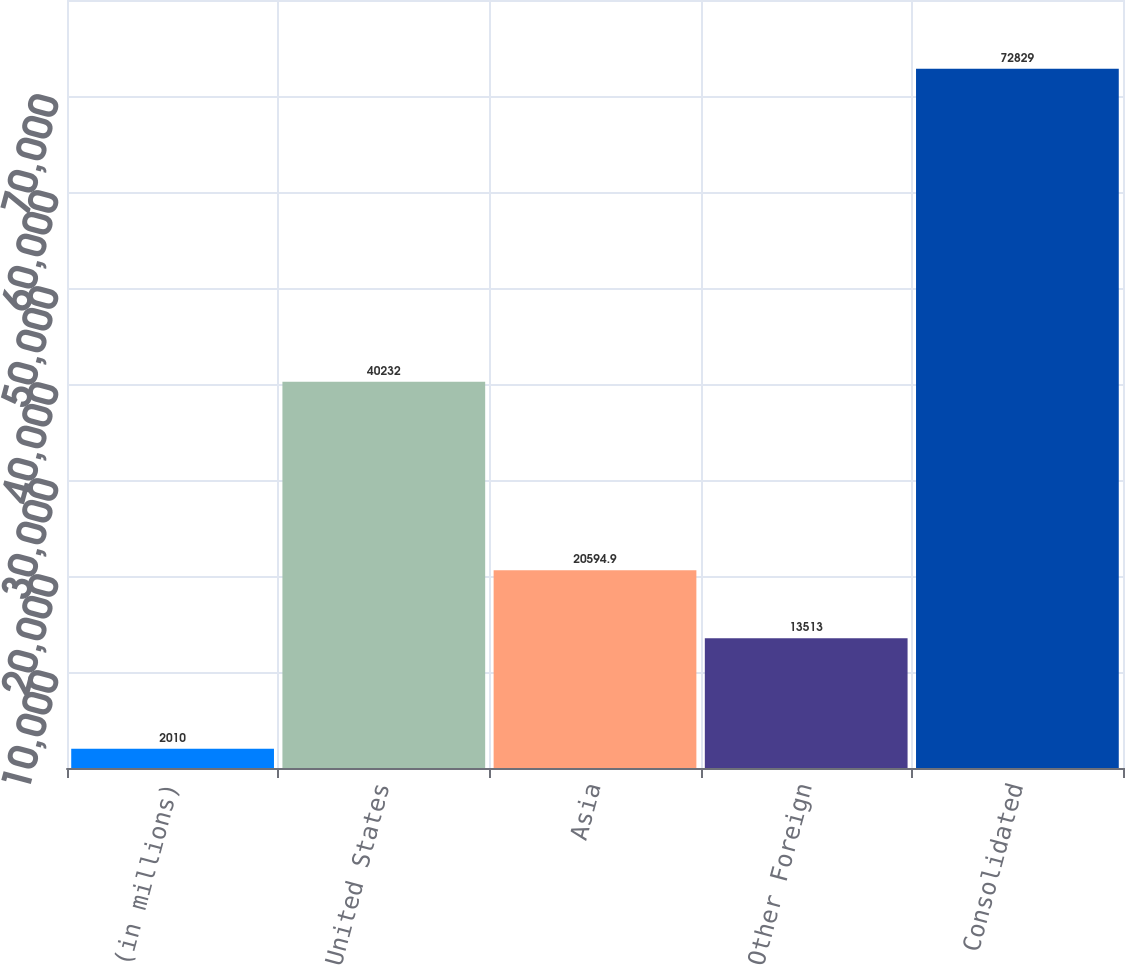<chart> <loc_0><loc_0><loc_500><loc_500><bar_chart><fcel>(in millions)<fcel>United States<fcel>Asia<fcel>Other Foreign<fcel>Consolidated<nl><fcel>2010<fcel>40232<fcel>20594.9<fcel>13513<fcel>72829<nl></chart> 